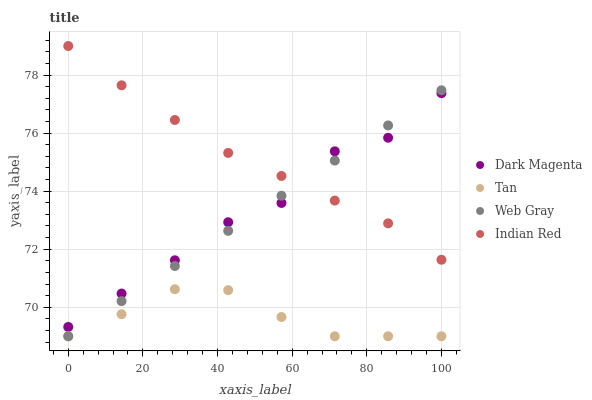Does Tan have the minimum area under the curve?
Answer yes or no. Yes. Does Indian Red have the maximum area under the curve?
Answer yes or no. Yes. Does Web Gray have the minimum area under the curve?
Answer yes or no. No. Does Web Gray have the maximum area under the curve?
Answer yes or no. No. Is Web Gray the smoothest?
Answer yes or no. Yes. Is Dark Magenta the roughest?
Answer yes or no. Yes. Is Dark Magenta the smoothest?
Answer yes or no. No. Is Web Gray the roughest?
Answer yes or no. No. Does Tan have the lowest value?
Answer yes or no. Yes. Does Dark Magenta have the lowest value?
Answer yes or no. No. Does Indian Red have the highest value?
Answer yes or no. Yes. Does Web Gray have the highest value?
Answer yes or no. No. Is Tan less than Indian Red?
Answer yes or no. Yes. Is Indian Red greater than Tan?
Answer yes or no. Yes. Does Indian Red intersect Dark Magenta?
Answer yes or no. Yes. Is Indian Red less than Dark Magenta?
Answer yes or no. No. Is Indian Red greater than Dark Magenta?
Answer yes or no. No. Does Tan intersect Indian Red?
Answer yes or no. No. 